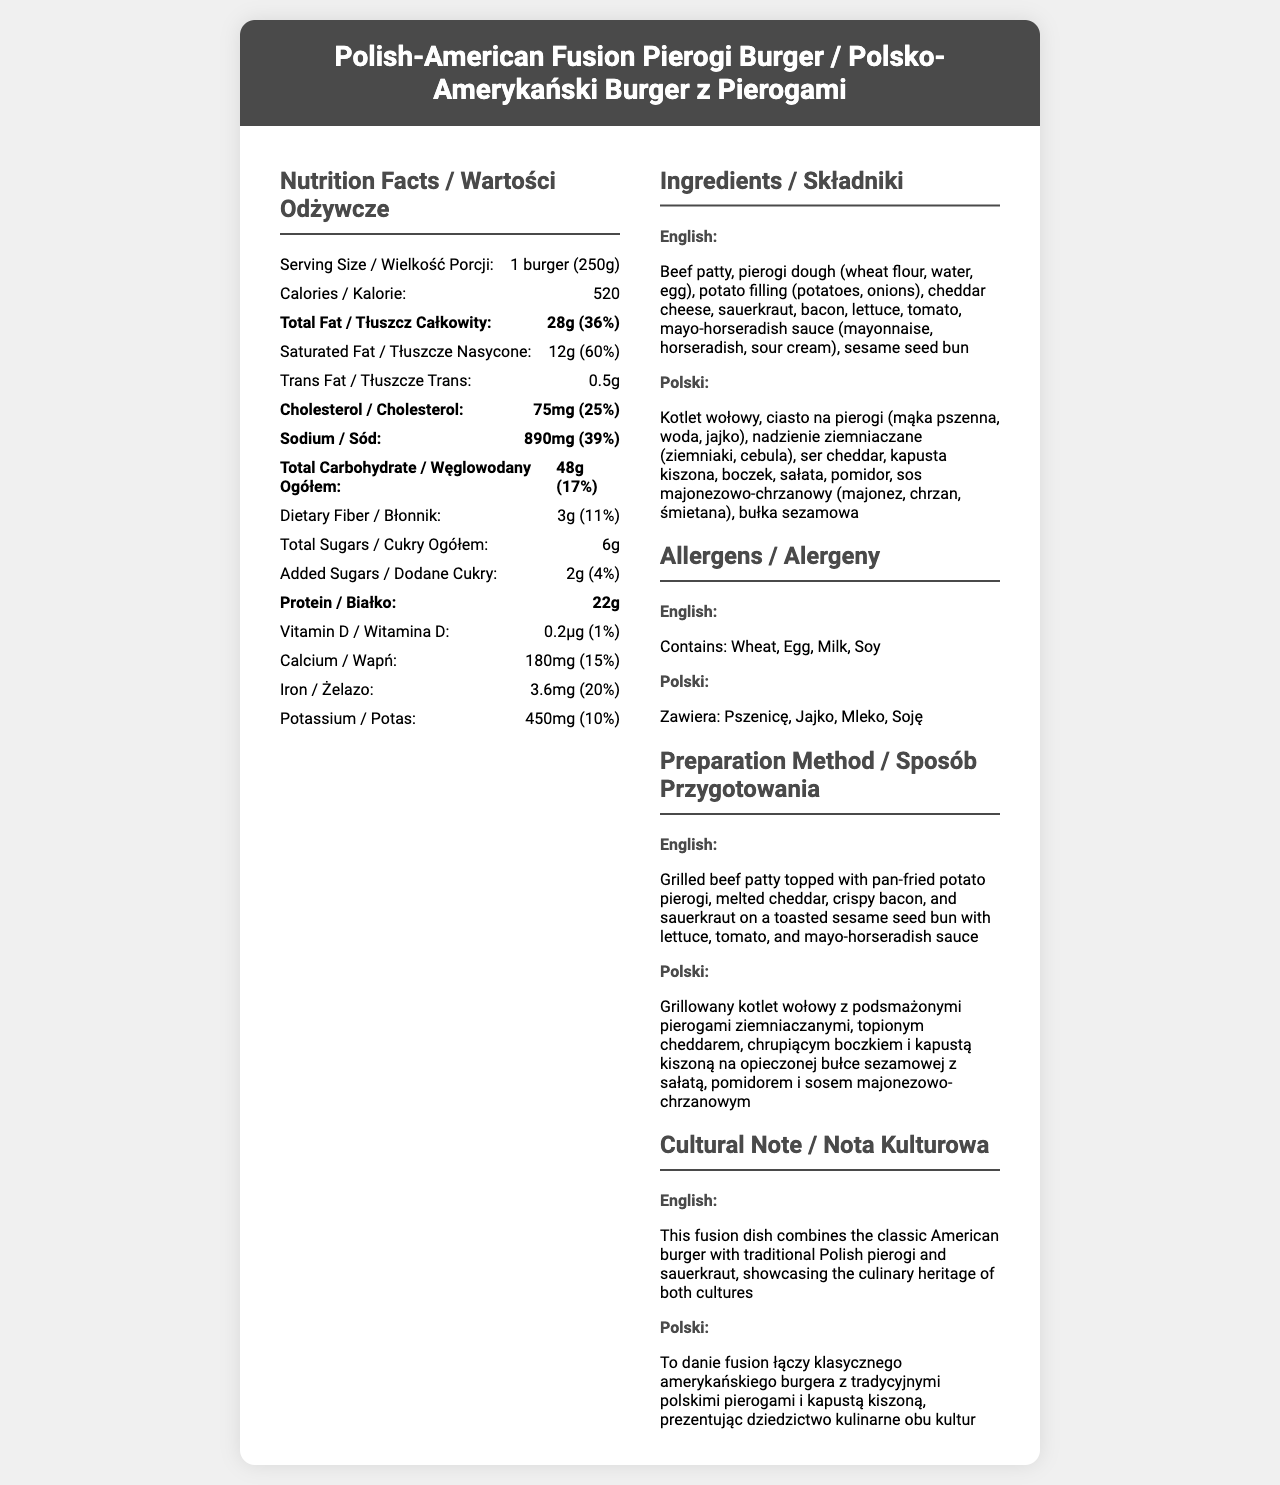what is the product name in English? The product name in English is clearly stated at the top of the document.
Answer: Polish-American Fusion Pierogi Burger What is the serving size in Polish? The serving size in Polish is provided in the language label section of the document.
Answer: 1 burger (250g) How many calories are there per serving? The document lists 520 calories per serving under the nutrition facts.
Answer: 520 What is the total fat content in grams? The total fat content is listed as 28 grams in the nutrition facts section.
Answer: 28 grams What allergens does this product contain? The allergens are listed in both English and Polish in the allergens section of the document.
Answer: Wheat, Egg, Milk, Soy Which nutrient has the highest percent daily value? A. Total Fat B. Saturated Fat C. Sodium D. Cholesterol Saturated fat has a percent daily value of 60%, which is the highest among the listed nutrients.
Answer: B. Saturated Fat How much sodium is in this product, in milligrams? A. 750 B. 800 C. 890 D. 950 The sodium content is listed as 890 milligrams in the nutrition facts section.
Answer: C. 890 Does the product contain any trans fats? The product contains 0.5 grams of trans fats according to the nutrition facts.
Answer: Yes Is there any Vitamin D in this product? The document shows that there is 0.2 micrograms of Vitamin D.
Answer: Yes Summarize the main idea of the document. The document aims to offer comprehensive nutritional and preparatory information about the product while highlighting its cultural significance by showcasing elements of both Polish and American cuisines.
Answer: The document provides bilingual nutrition facts for a Polish-American Fusion Pierogi Burger, detailing ingredients, allergens, preparation method, and a cultural note in both English and Polish. What is the preparation method in Polish? The preparation method in Polish is provided under the "Preparation Method" section of the document.
Answer: Grillowany kotlet wołowy z podsmażonymi pierogami ziemniaczanymi, topionym cheddarem, chrupiącym boczkiem i kapustą kiszoną na opieczonej bułce sezamowej z sałatą, pomidorem i sosem majonezowo-chrzanowym How much protein is in a single serving? The protein content per serving is listed as 22 grams in the nutrition facts section.
Answer: 22 grams Does the product contain any added sugars? The document specifies that the product contains 2 grams of added sugars.
Answer: Yes What are the main ingredients in the pierogi dough? The ingredients for the pierogi dough are listed as wheat flour, water, and egg in both the English and Polish sections of the ingredients list.
Answer: Wheat flour, water, egg Is there more calcium or potassium in this product? The product contains 450 milligrams of potassium compared to 180 milligrams of calcium.
Answer: Potassium What is the cultural note about this dish in English? The cultural note in English explains the fusion of the classic American burger with traditional Polish elements.
Answer: This fusion dish combines the classic American burger with traditional Polish pierogi and sauerkraut, showcasing the culinary heritage of both cultures How many servings are there per container? The document mentions that there is 1 serving per container.
Answer: 1 What is not clear about the vitamin and mineral content? Although some vitamins and minerals are listed (like Vitamin D, Calcium, Iron, Potassium), the document does not provide comprehensive information about all vitamins and minerals, such as specific daily percentage values for some of them.
Answer: Exact percentage daily values for certain vitamins and minerals like Vitamin D are not detailed beyond a mere presence 